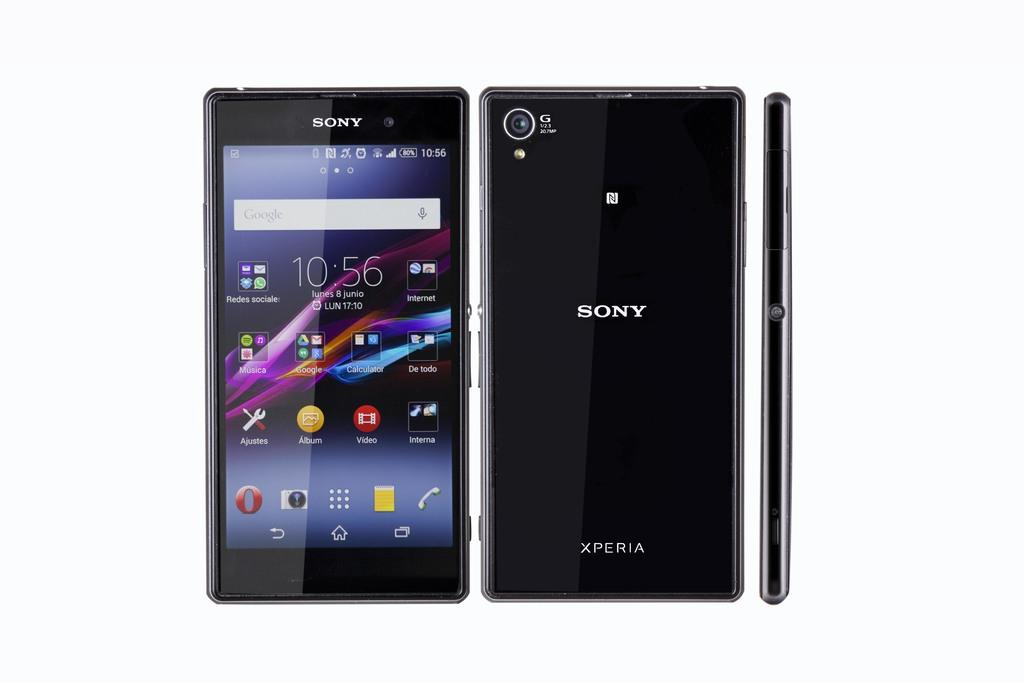<image>
Relay a brief, clear account of the picture shown. A smart phone that says Sony Xperia is on a background and shows the time 10:56. 